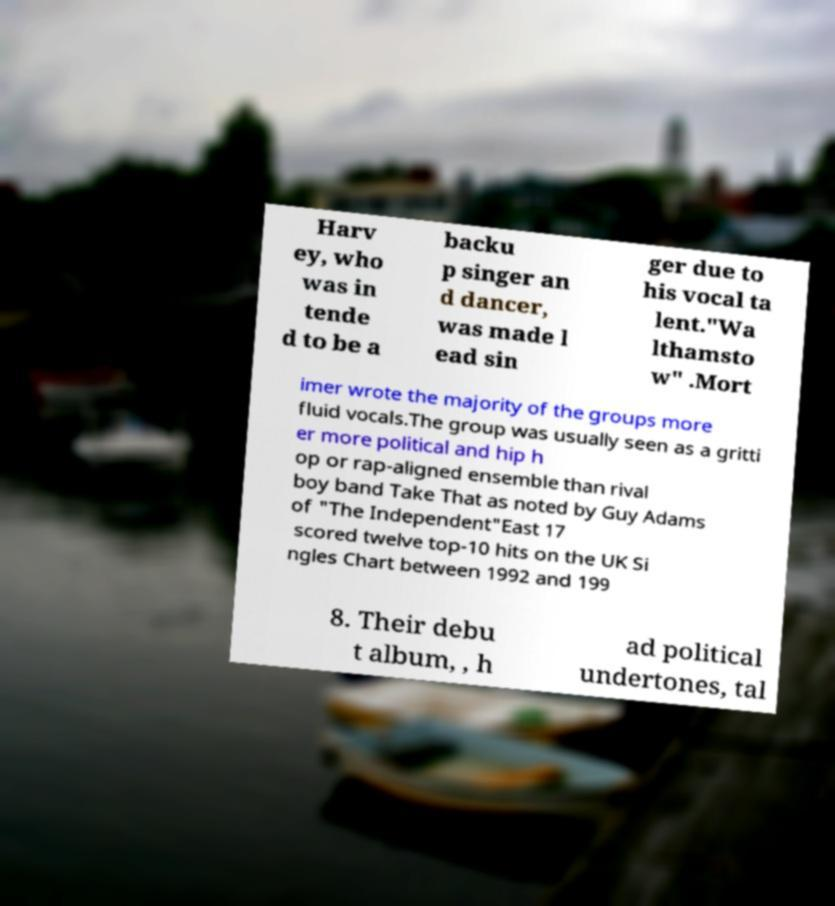I need the written content from this picture converted into text. Can you do that? Harv ey, who was in tende d to be a backu p singer an d dancer, was made l ead sin ger due to his vocal ta lent."Wa lthamsto w" .Mort imer wrote the majority of the groups more fluid vocals.The group was usually seen as a gritti er more political and hip h op or rap-aligned ensemble than rival boy band Take That as noted by Guy Adams of "The Independent"East 17 scored twelve top-10 hits on the UK Si ngles Chart between 1992 and 199 8. Their debu t album, , h ad political undertones, tal 